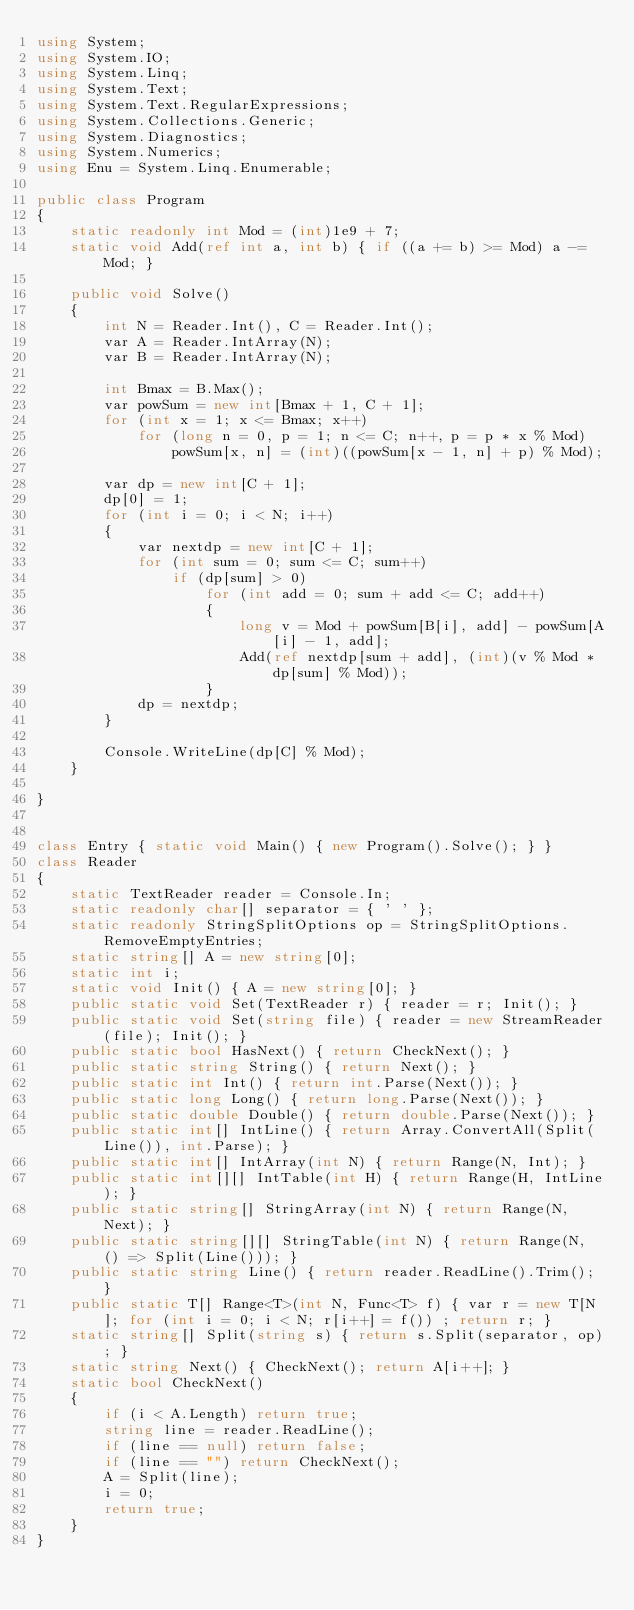Convert code to text. <code><loc_0><loc_0><loc_500><loc_500><_C#_>using System;
using System.IO;
using System.Linq;
using System.Text;
using System.Text.RegularExpressions;
using System.Collections.Generic;
using System.Diagnostics;
using System.Numerics;
using Enu = System.Linq.Enumerable;

public class Program
{
    static readonly int Mod = (int)1e9 + 7;
    static void Add(ref int a, int b) { if ((a += b) >= Mod) a -= Mod; }

    public void Solve()
    {
        int N = Reader.Int(), C = Reader.Int();
        var A = Reader.IntArray(N);
        var B = Reader.IntArray(N);

        int Bmax = B.Max();
        var powSum = new int[Bmax + 1, C + 1];
        for (int x = 1; x <= Bmax; x++)
            for (long n = 0, p = 1; n <= C; n++, p = p * x % Mod)
                powSum[x, n] = (int)((powSum[x - 1, n] + p) % Mod);

        var dp = new int[C + 1];
        dp[0] = 1;
        for (int i = 0; i < N; i++)
        {
            var nextdp = new int[C + 1];
            for (int sum = 0; sum <= C; sum++)
                if (dp[sum] > 0)
                    for (int add = 0; sum + add <= C; add++)
                    {
                        long v = Mod + powSum[B[i], add] - powSum[A[i] - 1, add];
                        Add(ref nextdp[sum + add], (int)(v % Mod * dp[sum] % Mod));
                    }
            dp = nextdp;
        }

        Console.WriteLine(dp[C] % Mod);
    }

}


class Entry { static void Main() { new Program().Solve(); } }
class Reader
{
    static TextReader reader = Console.In;
    static readonly char[] separator = { ' ' };
    static readonly StringSplitOptions op = StringSplitOptions.RemoveEmptyEntries;
    static string[] A = new string[0];
    static int i;
    static void Init() { A = new string[0]; }
    public static void Set(TextReader r) { reader = r; Init(); }
    public static void Set(string file) { reader = new StreamReader(file); Init(); }
    public static bool HasNext() { return CheckNext(); }
    public static string String() { return Next(); }
    public static int Int() { return int.Parse(Next()); }
    public static long Long() { return long.Parse(Next()); }
    public static double Double() { return double.Parse(Next()); }
    public static int[] IntLine() { return Array.ConvertAll(Split(Line()), int.Parse); }
    public static int[] IntArray(int N) { return Range(N, Int); }
    public static int[][] IntTable(int H) { return Range(H, IntLine); }
    public static string[] StringArray(int N) { return Range(N, Next); }
    public static string[][] StringTable(int N) { return Range(N, () => Split(Line())); }
    public static string Line() { return reader.ReadLine().Trim(); }
    public static T[] Range<T>(int N, Func<T> f) { var r = new T[N]; for (int i = 0; i < N; r[i++] = f()) ; return r; }
    static string[] Split(string s) { return s.Split(separator, op); }
    static string Next() { CheckNext(); return A[i++]; }
    static bool CheckNext()
    {
        if (i < A.Length) return true;
        string line = reader.ReadLine();
        if (line == null) return false;
        if (line == "") return CheckNext();
        A = Split(line);
        i = 0;
        return true;
    }
}</code> 